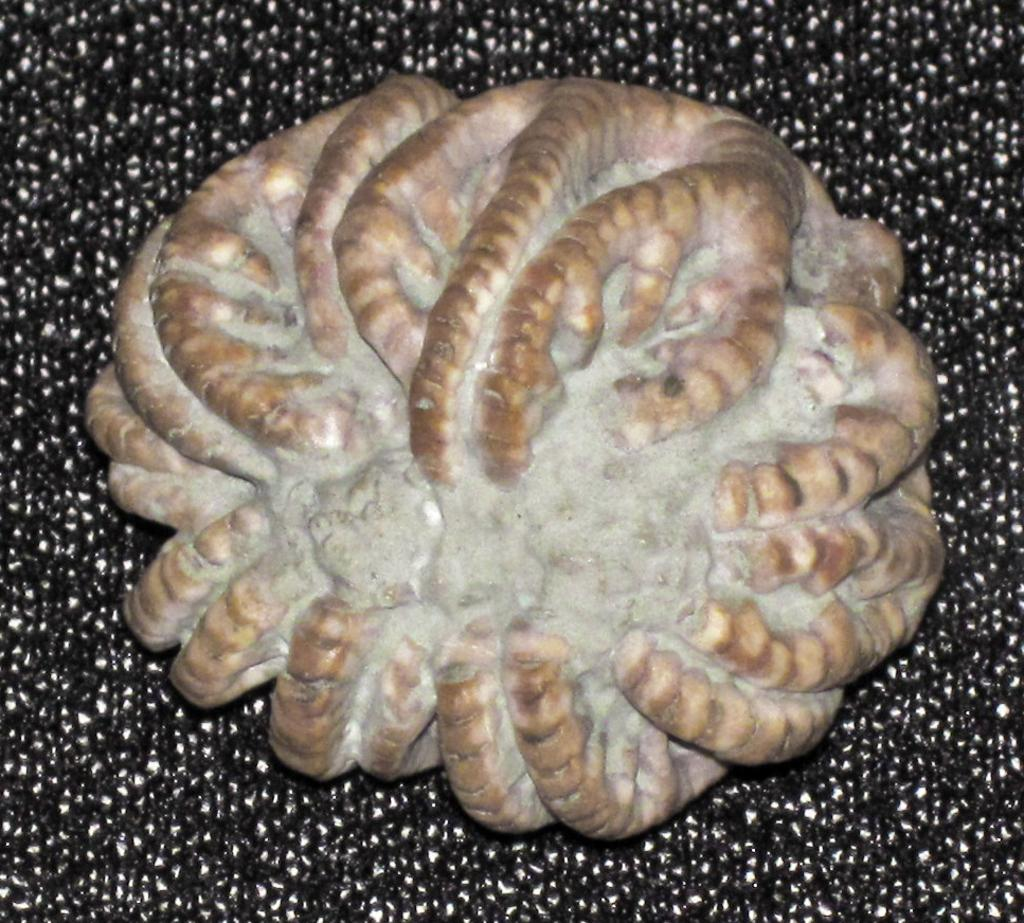What can be seen in the image? There is an item in the image. How does the item in the image help with debt? The item in the image does not address or relate to debt, as there is no information provided about its purpose or function. 